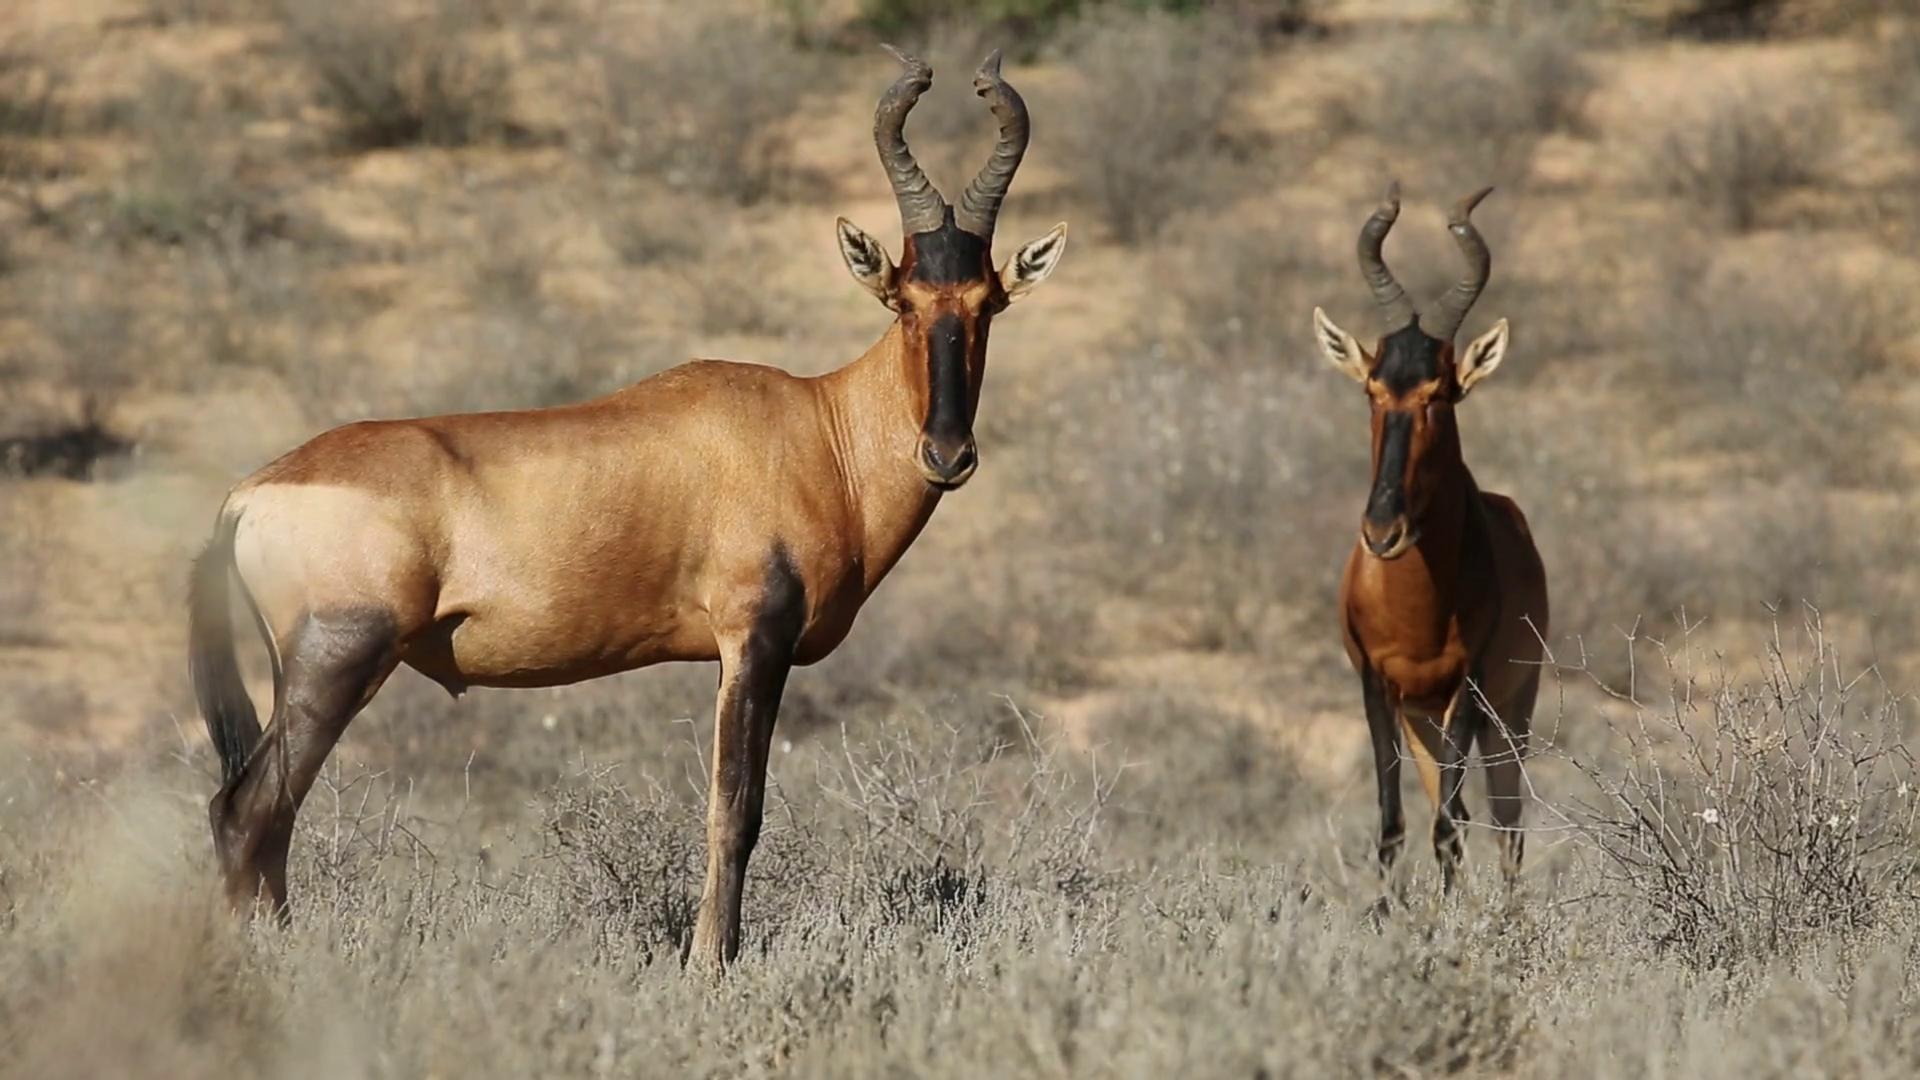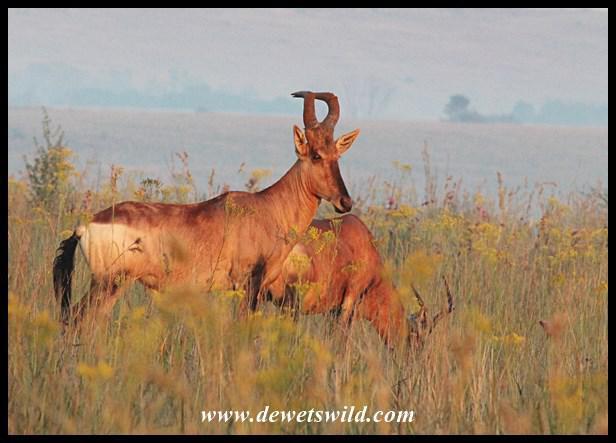The first image is the image on the left, the second image is the image on the right. Analyze the images presented: Is the assertion "One image contains at least one hornless deer-like animal with vertical white stripes, and the other image features multiple animals with curved horns and at least one reclining animal." valid? Answer yes or no. No. The first image is the image on the left, the second image is the image on the right. Given the left and right images, does the statement "All the animals have horns." hold true? Answer yes or no. Yes. 